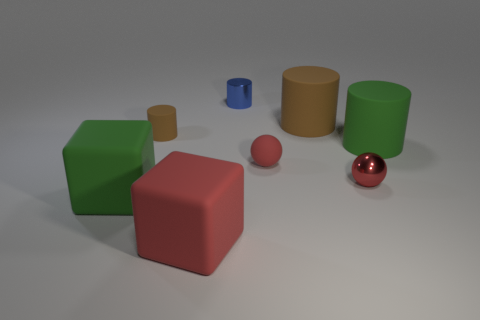Subtract all small blue metal cylinders. How many cylinders are left? 3 Subtract all green cylinders. How many cylinders are left? 3 Add 2 large green rubber cylinders. How many objects exist? 10 Subtract all cyan cylinders. Subtract all blue blocks. How many cylinders are left? 4 Subtract all spheres. How many objects are left? 6 Add 7 large matte cylinders. How many large matte cylinders are left? 9 Add 8 blue shiny objects. How many blue shiny objects exist? 9 Subtract 0 gray spheres. How many objects are left? 8 Subtract all small brown cylinders. Subtract all balls. How many objects are left? 5 